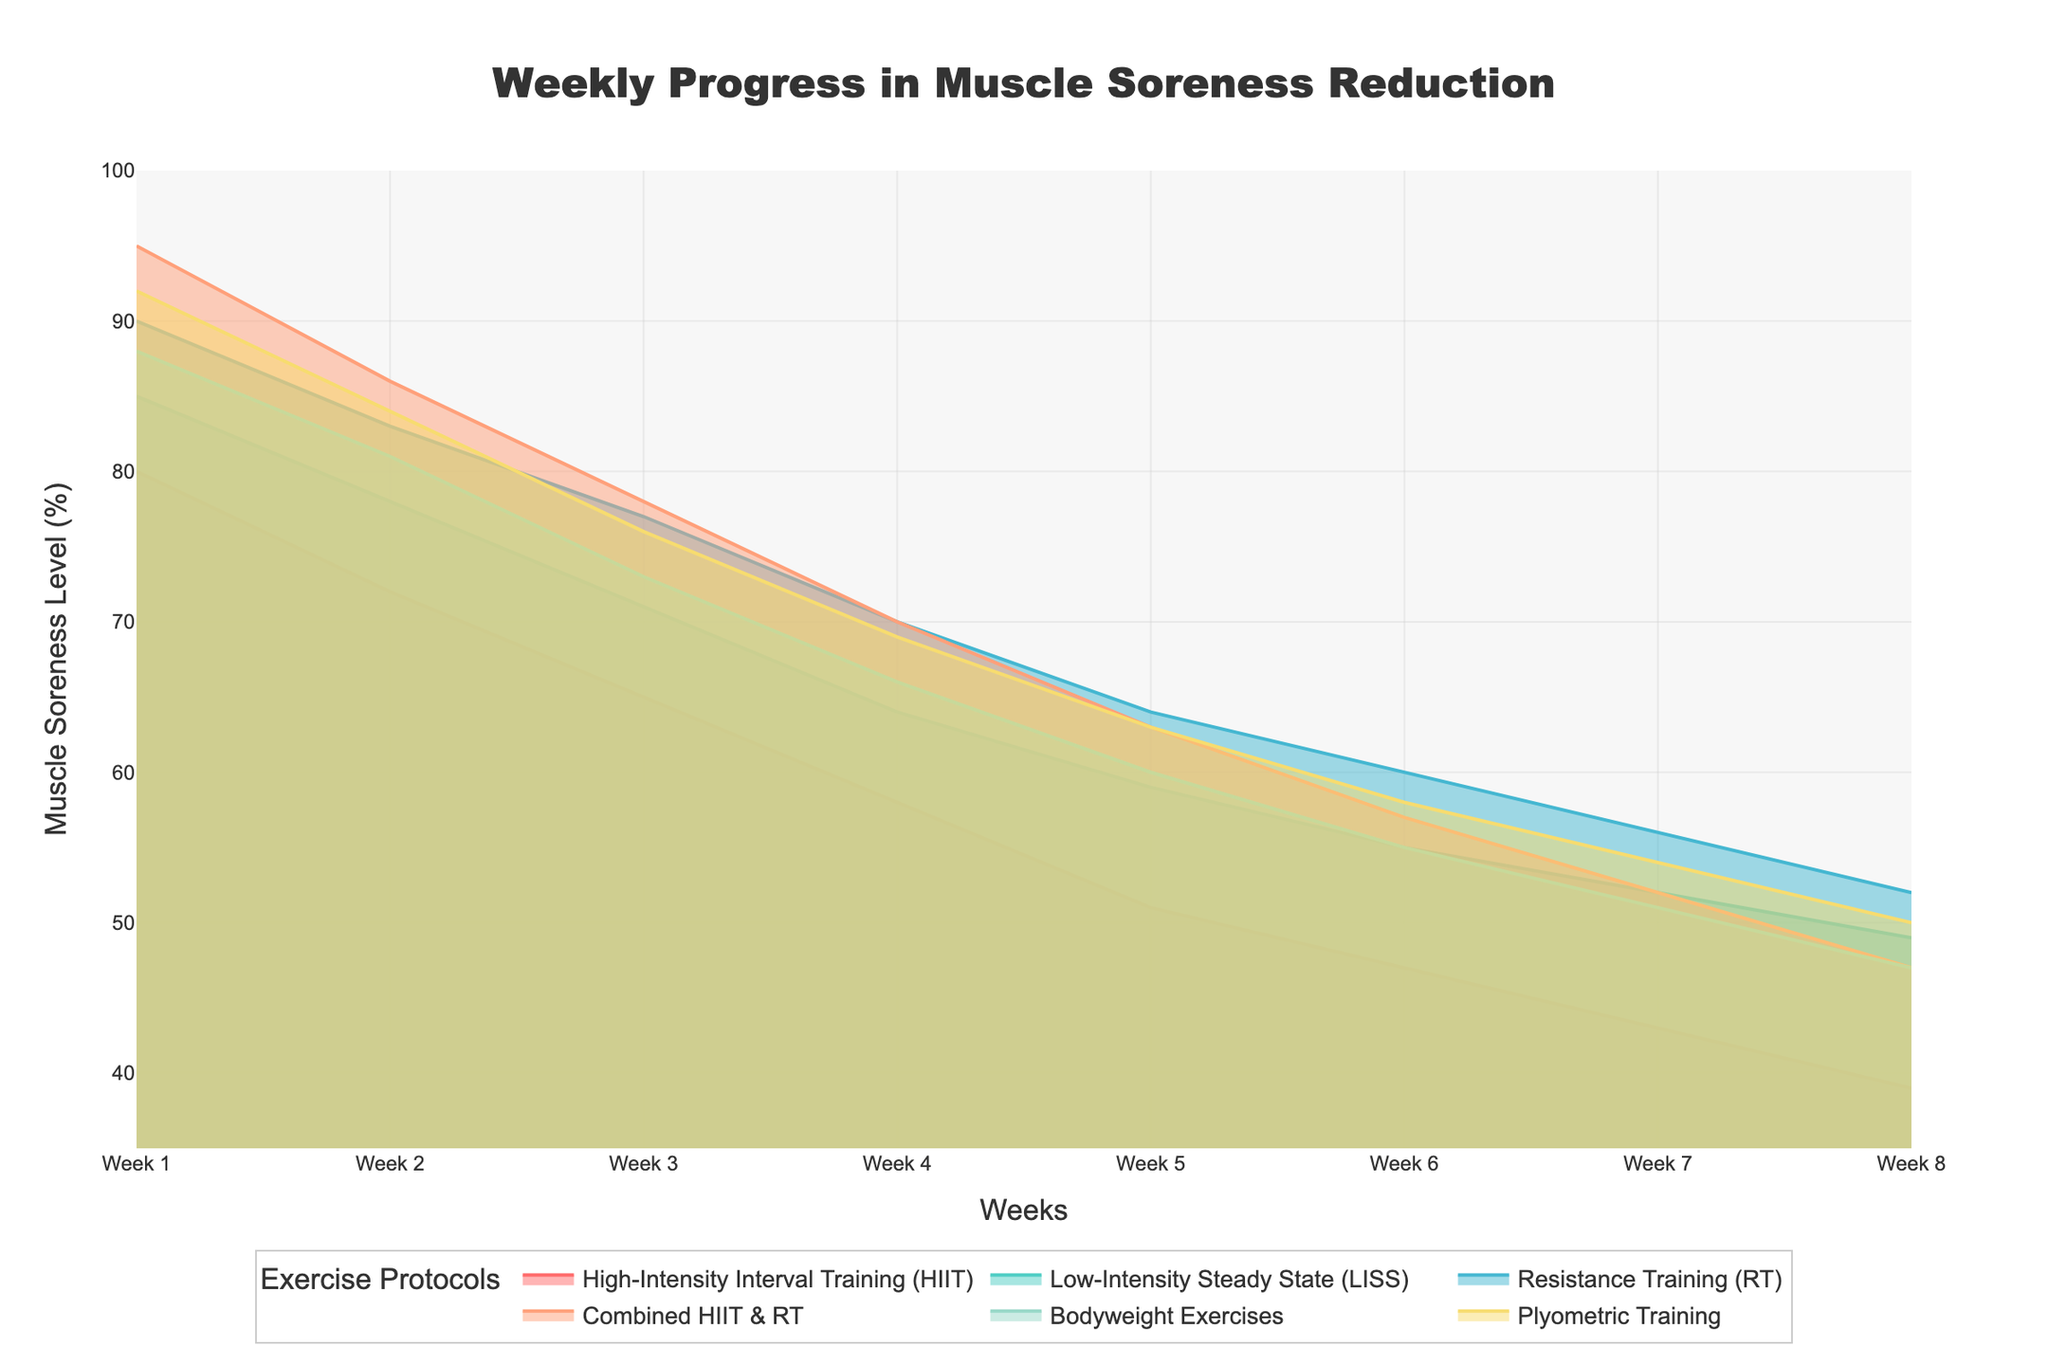What is the title of the chart? The title of the chart is prominently displayed at the top of the figure.
Answer: Weekly Progress in Muscle Soreness Reduction Which protocol shows the fastest initial reduction in muscle soreness by the second week? By examining the reduction in soreness levels from Week 1 to Week 2 for each protocol, we see that the 'Combined HIIT & RT' protocol shows the highest percentage drop.
Answer: Combined HIIT & RT How much does muscle soreness reduce by Week 8 in the Low-Intensity Steady State (LISS) protocol? The chart shows the muscle soreness levels for each protocol across 8 weeks. For Low-Intensity Steady State (LISS), the soreness level at Week 8 is 49%.
Answer: 49% Compare the muscle soreness reduction between High-Intensity Interval Training (HIIT) and Resistance Training (RT) by Week 4. Which one has a higher reduction? By Week 4, the muscle soreness levels are given for both protocols. HIIT goes from 80% to 58%, a reduction of 22%. Resistance Training goes from 90% to 70%, a reduction of 20%. Therefore, HIIT has a higher reduction.
Answer: High-Intensity Interval Training (HIIT) By how much does the muscle soreness level decrease in Bodyweight Exercises from Week 5 to Week 8? For the Bodyweight Exercises protocol, the muscle soreness levels at Week 5 and Week 8 are 60% and 47%, respectively. The reduction is 60% - 47% = 13%.
Answer: 13% Which protocol has the least reduction in muscle soreness by the end of Week 8? Look at the final soreness levels for all protocols at Week 8. The Resistance Training (RT) protocol has the highest value (52%) among all, indicating the least reduction.
Answer: Resistance Training (RT) What is the difference in muscle soreness levels between Plyometric Training and Bodyweight Exercises at Week 6? The chart indicates muscle soreness levels at Week 6. For Plyometric Training, it's 58%, and for Bodyweight Exercises, it's 55%, making the difference 58% - 55% = 3%.
Answer: 3% Which protocol exhibits a consistent decrease in muscle soreness without any plateaus or increases throughout all 8 weeks? Observing the trends for all protocols, all of them exhibit a consistent decrease, as there are no plateaus or increases in any of the protocols over the 8-week period.
Answer: All protocols 